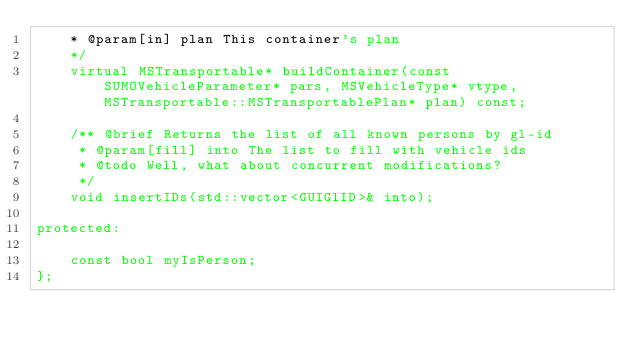Convert code to text. <code><loc_0><loc_0><loc_500><loc_500><_C_>    * @param[in] plan This container's plan
    */
    virtual MSTransportable* buildContainer(const SUMOVehicleParameter* pars, MSVehicleType* vtype, MSTransportable::MSTransportablePlan* plan) const;

    /** @brief Returns the list of all known persons by gl-id
     * @param[fill] into The list to fill with vehicle ids
     * @todo Well, what about concurrent modifications?
     */
    void insertIDs(std::vector<GUIGlID>& into);

protected:

    const bool myIsPerson;
};
</code> 